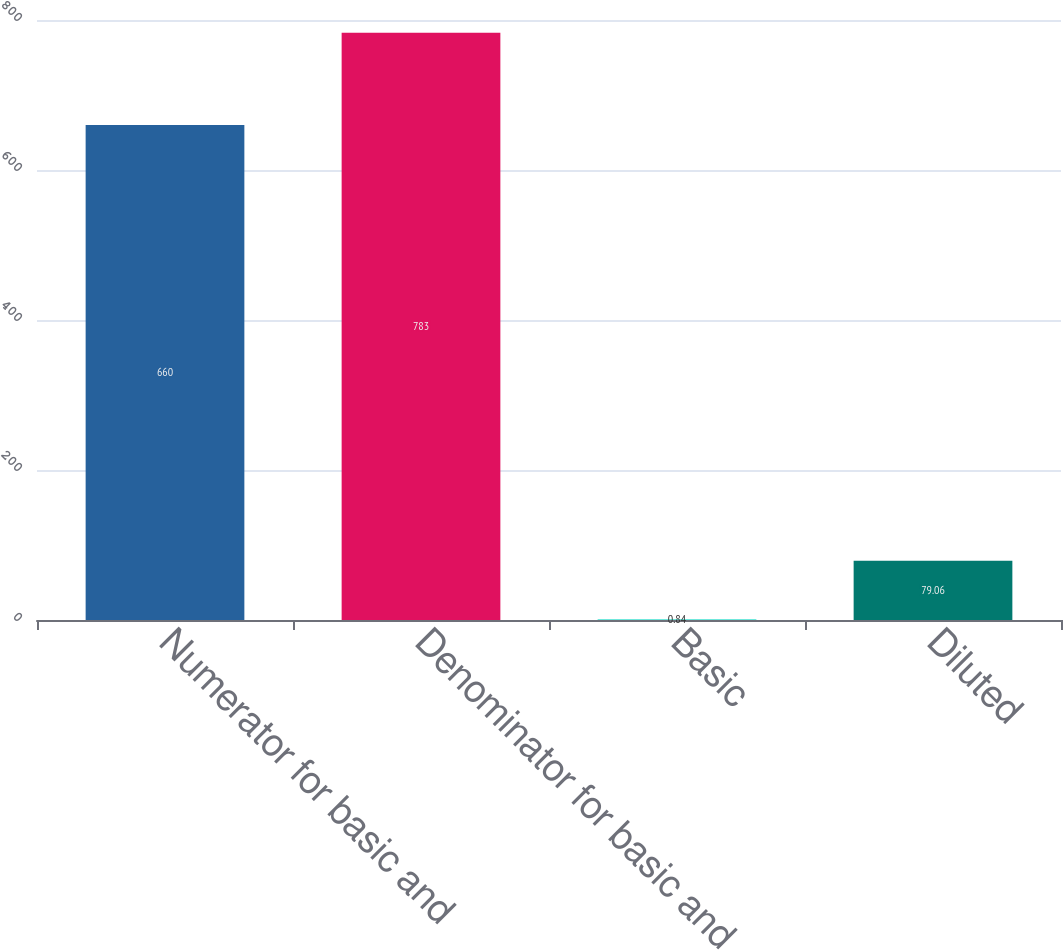Convert chart. <chart><loc_0><loc_0><loc_500><loc_500><bar_chart><fcel>Numerator for basic and<fcel>Denominator for basic and<fcel>Basic<fcel>Diluted<nl><fcel>660<fcel>783<fcel>0.84<fcel>79.06<nl></chart> 